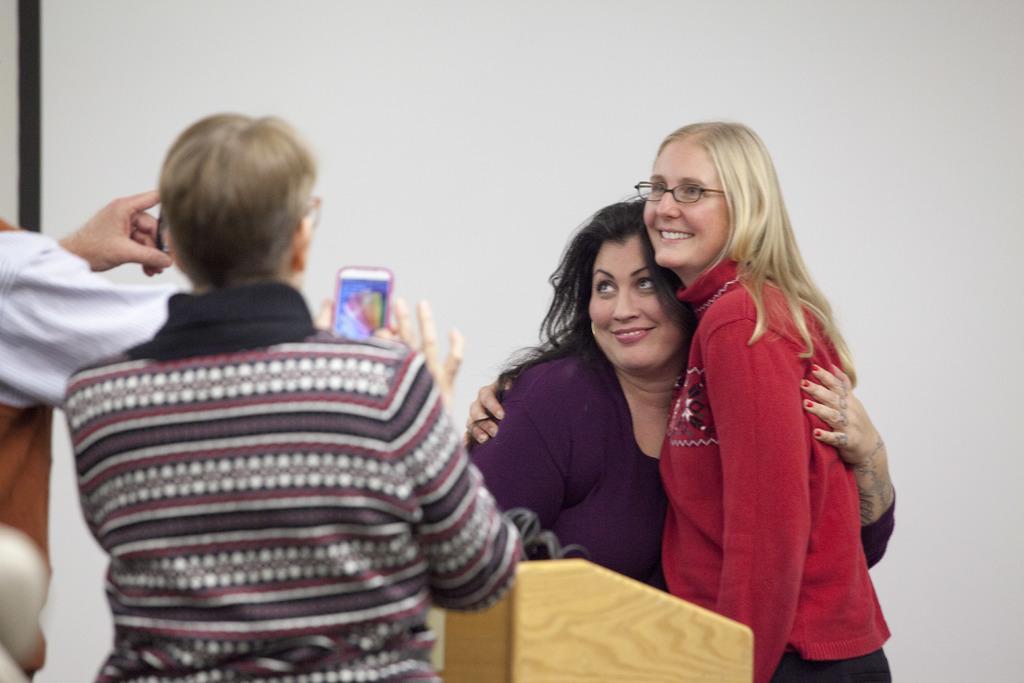Describe this image in one or two sentences. In this image I can see there are two girls hanging to each other and they are smiling and one person taking the picture of another person and I can see a person hand visible on the left side and in the background white color visible. 